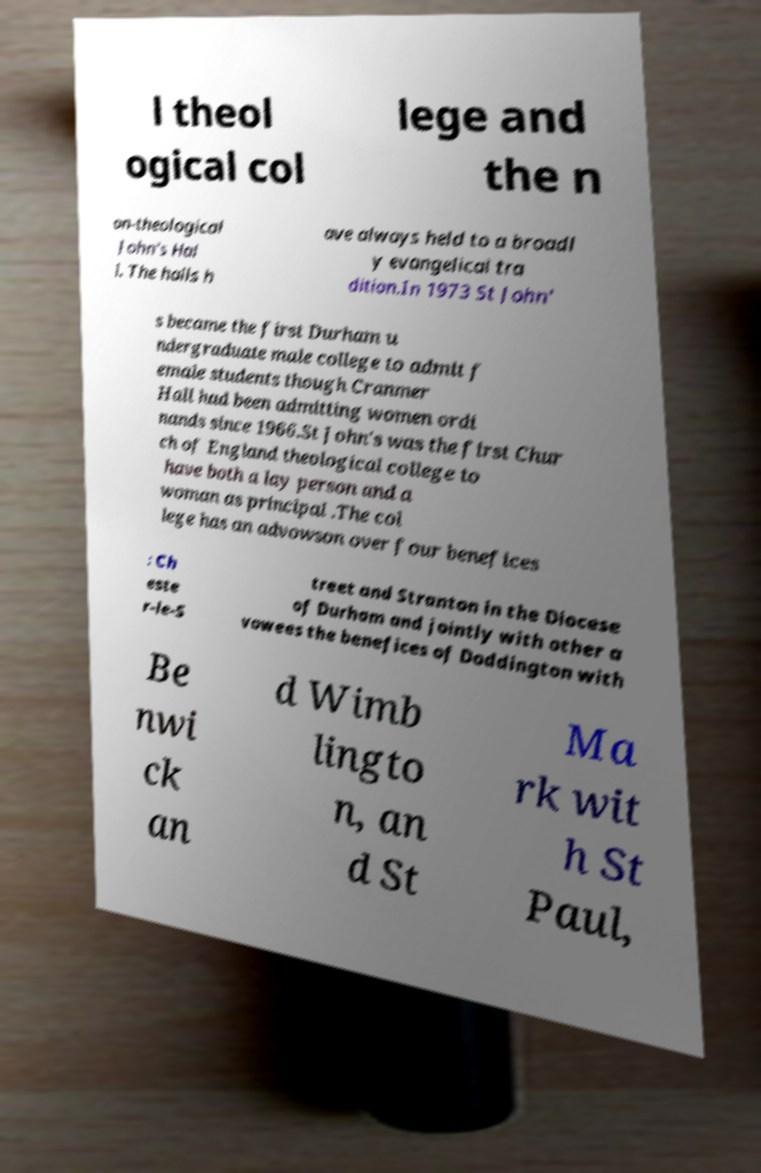Can you read and provide the text displayed in the image?This photo seems to have some interesting text. Can you extract and type it out for me? l theol ogical col lege and the n on-theological John's Hal l. The halls h ave always held to a broadl y evangelical tra dition.In 1973 St John' s became the first Durham u ndergraduate male college to admit f emale students though Cranmer Hall had been admitting women ordi nands since 1966.St John's was the first Chur ch of England theological college to have both a lay person and a woman as principal .The col lege has an advowson over four benefices : Ch este r-le-S treet and Stranton in the Diocese of Durham and jointly with other a vowees the benefices of Doddington with Be nwi ck an d Wimb lingto n, an d St Ma rk wit h St Paul, 